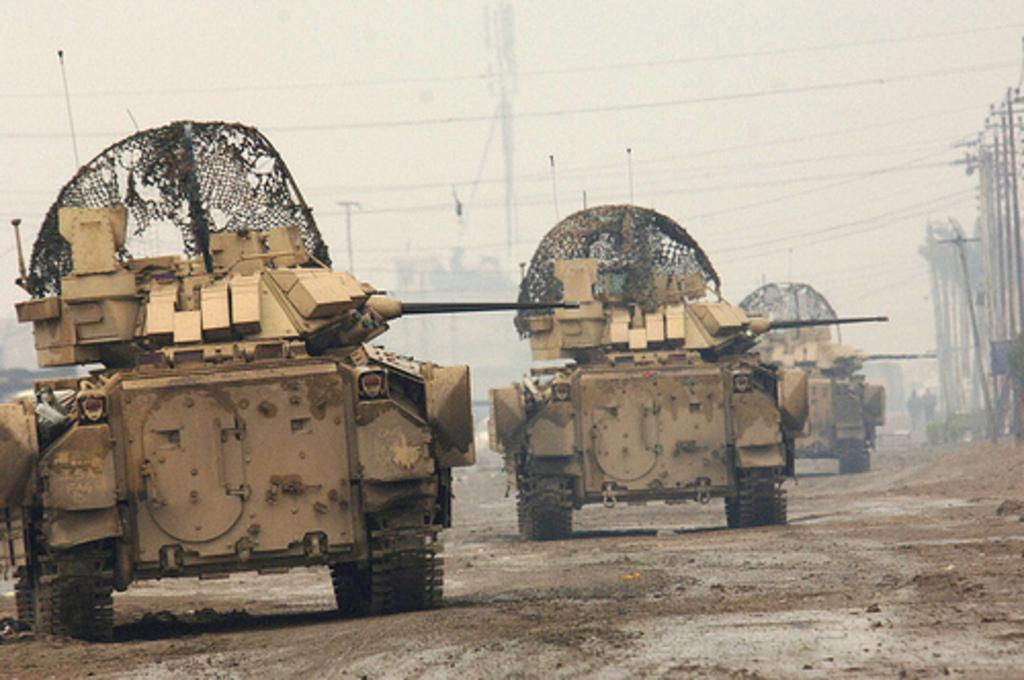What type of vehicles are present in the image? There are vehicles in the image that resemble tanks. What can be seen on the right side of the image? There are poles on the right side of the image. What are the poles connected to? Wires are attached to the poles. What is visible in the background of the image? The sky is visible in the background of the image. What type of instrument is being played by the banana in the image? There is no banana or instrument present in the image. What type of beetle can be seen crawling on the tank in the image? There are no beetles present in the image; only vehicles and poles with wires are visible. 